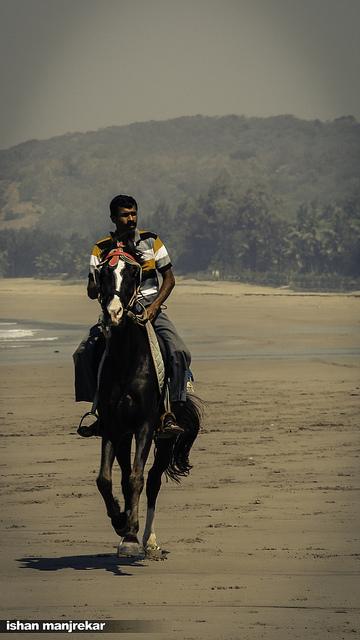What is the race of the man riding the horse?
Write a very short answer. Black. Is the horse in the air?
Concise answer only. No. Does this person and horse reside in a lush environment?
Be succinct. Yes. Is there something on the horse's head?
Give a very brief answer. Yes. Are the riders wearing helmets?
Answer briefly. No. 